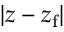<formula> <loc_0><loc_0><loc_500><loc_500>| z - z _ { f } |</formula> 